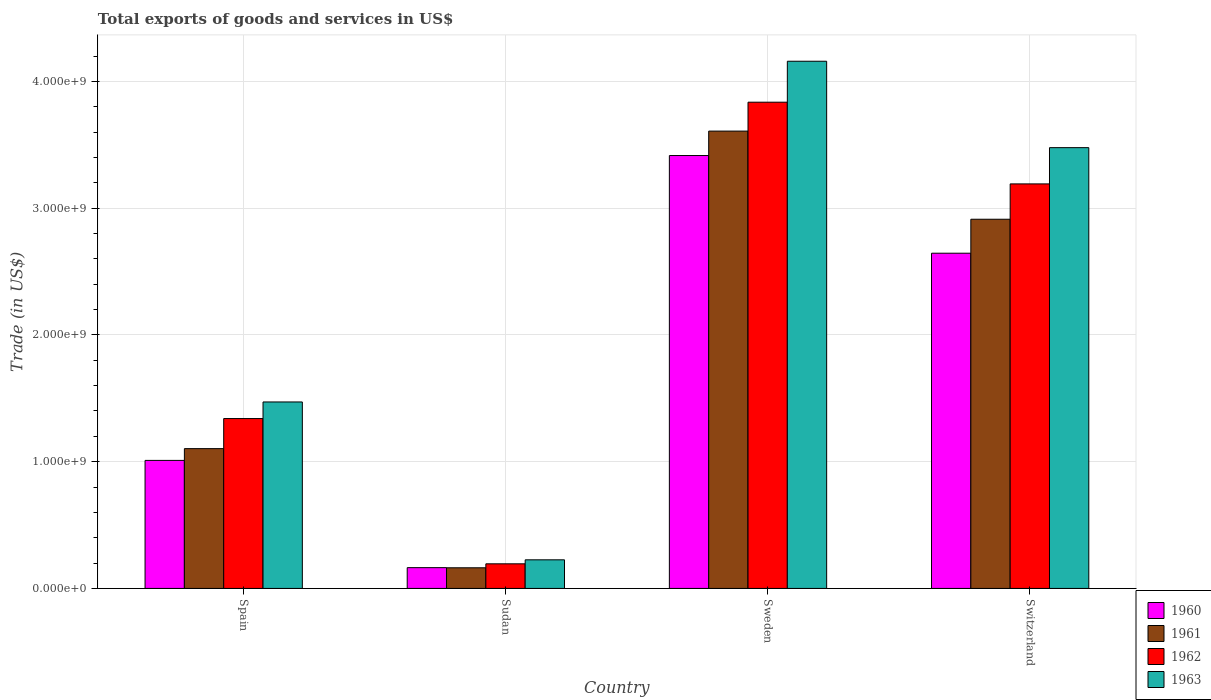Are the number of bars per tick equal to the number of legend labels?
Ensure brevity in your answer.  Yes. Are the number of bars on each tick of the X-axis equal?
Your response must be concise. Yes. What is the total exports of goods and services in 1963 in Switzerland?
Ensure brevity in your answer.  3.48e+09. Across all countries, what is the maximum total exports of goods and services in 1960?
Offer a terse response. 3.42e+09. Across all countries, what is the minimum total exports of goods and services in 1963?
Your response must be concise. 2.26e+08. In which country was the total exports of goods and services in 1963 maximum?
Ensure brevity in your answer.  Sweden. In which country was the total exports of goods and services in 1963 minimum?
Ensure brevity in your answer.  Sudan. What is the total total exports of goods and services in 1960 in the graph?
Give a very brief answer. 7.23e+09. What is the difference between the total exports of goods and services in 1960 in Sudan and that in Switzerland?
Make the answer very short. -2.48e+09. What is the difference between the total exports of goods and services in 1961 in Switzerland and the total exports of goods and services in 1962 in Spain?
Keep it short and to the point. 1.57e+09. What is the average total exports of goods and services in 1962 per country?
Ensure brevity in your answer.  2.14e+09. What is the difference between the total exports of goods and services of/in 1962 and total exports of goods and services of/in 1960 in Switzerland?
Your answer should be very brief. 5.47e+08. In how many countries, is the total exports of goods and services in 1963 greater than 2800000000 US$?
Your answer should be very brief. 2. What is the ratio of the total exports of goods and services in 1961 in Sudan to that in Sweden?
Your answer should be compact. 0.05. Is the total exports of goods and services in 1963 in Spain less than that in Switzerland?
Provide a succinct answer. Yes. Is the difference between the total exports of goods and services in 1962 in Spain and Sudan greater than the difference between the total exports of goods and services in 1960 in Spain and Sudan?
Your answer should be very brief. Yes. What is the difference between the highest and the second highest total exports of goods and services in 1960?
Offer a terse response. -7.71e+08. What is the difference between the highest and the lowest total exports of goods and services in 1961?
Your response must be concise. 3.44e+09. Is the sum of the total exports of goods and services in 1960 in Sweden and Switzerland greater than the maximum total exports of goods and services in 1963 across all countries?
Give a very brief answer. Yes. Is it the case that in every country, the sum of the total exports of goods and services in 1961 and total exports of goods and services in 1960 is greater than the sum of total exports of goods and services in 1962 and total exports of goods and services in 1963?
Offer a very short reply. No. What does the 2nd bar from the left in Switzerland represents?
Give a very brief answer. 1961. What does the 4th bar from the right in Switzerland represents?
Provide a succinct answer. 1960. Is it the case that in every country, the sum of the total exports of goods and services in 1961 and total exports of goods and services in 1962 is greater than the total exports of goods and services in 1960?
Offer a terse response. Yes. How many bars are there?
Provide a succinct answer. 16. Are all the bars in the graph horizontal?
Your answer should be compact. No. How many countries are there in the graph?
Provide a short and direct response. 4. What is the difference between two consecutive major ticks on the Y-axis?
Ensure brevity in your answer.  1.00e+09. Does the graph contain any zero values?
Your answer should be very brief. No. Where does the legend appear in the graph?
Ensure brevity in your answer.  Bottom right. How many legend labels are there?
Your answer should be very brief. 4. How are the legend labels stacked?
Provide a succinct answer. Vertical. What is the title of the graph?
Your answer should be very brief. Total exports of goods and services in US$. Does "1971" appear as one of the legend labels in the graph?
Make the answer very short. No. What is the label or title of the X-axis?
Keep it short and to the point. Country. What is the label or title of the Y-axis?
Give a very brief answer. Trade (in US$). What is the Trade (in US$) of 1960 in Spain?
Your answer should be very brief. 1.01e+09. What is the Trade (in US$) of 1961 in Spain?
Make the answer very short. 1.10e+09. What is the Trade (in US$) of 1962 in Spain?
Offer a very short reply. 1.34e+09. What is the Trade (in US$) in 1963 in Spain?
Keep it short and to the point. 1.47e+09. What is the Trade (in US$) in 1960 in Sudan?
Provide a succinct answer. 1.64e+08. What is the Trade (in US$) in 1961 in Sudan?
Ensure brevity in your answer.  1.63e+08. What is the Trade (in US$) of 1962 in Sudan?
Offer a terse response. 1.94e+08. What is the Trade (in US$) of 1963 in Sudan?
Keep it short and to the point. 2.26e+08. What is the Trade (in US$) in 1960 in Sweden?
Keep it short and to the point. 3.42e+09. What is the Trade (in US$) in 1961 in Sweden?
Your answer should be very brief. 3.61e+09. What is the Trade (in US$) of 1962 in Sweden?
Ensure brevity in your answer.  3.84e+09. What is the Trade (in US$) of 1963 in Sweden?
Offer a terse response. 4.16e+09. What is the Trade (in US$) of 1960 in Switzerland?
Provide a succinct answer. 2.64e+09. What is the Trade (in US$) in 1961 in Switzerland?
Make the answer very short. 2.91e+09. What is the Trade (in US$) in 1962 in Switzerland?
Give a very brief answer. 3.19e+09. What is the Trade (in US$) in 1963 in Switzerland?
Your answer should be compact. 3.48e+09. Across all countries, what is the maximum Trade (in US$) in 1960?
Give a very brief answer. 3.42e+09. Across all countries, what is the maximum Trade (in US$) in 1961?
Make the answer very short. 3.61e+09. Across all countries, what is the maximum Trade (in US$) of 1962?
Provide a short and direct response. 3.84e+09. Across all countries, what is the maximum Trade (in US$) of 1963?
Keep it short and to the point. 4.16e+09. Across all countries, what is the minimum Trade (in US$) of 1960?
Provide a succinct answer. 1.64e+08. Across all countries, what is the minimum Trade (in US$) in 1961?
Provide a succinct answer. 1.63e+08. Across all countries, what is the minimum Trade (in US$) of 1962?
Give a very brief answer. 1.94e+08. Across all countries, what is the minimum Trade (in US$) of 1963?
Provide a succinct answer. 2.26e+08. What is the total Trade (in US$) of 1960 in the graph?
Provide a succinct answer. 7.23e+09. What is the total Trade (in US$) in 1961 in the graph?
Ensure brevity in your answer.  7.79e+09. What is the total Trade (in US$) in 1962 in the graph?
Provide a succinct answer. 8.56e+09. What is the total Trade (in US$) of 1963 in the graph?
Your answer should be compact. 9.33e+09. What is the difference between the Trade (in US$) in 1960 in Spain and that in Sudan?
Your answer should be very brief. 8.46e+08. What is the difference between the Trade (in US$) of 1961 in Spain and that in Sudan?
Provide a succinct answer. 9.40e+08. What is the difference between the Trade (in US$) of 1962 in Spain and that in Sudan?
Give a very brief answer. 1.15e+09. What is the difference between the Trade (in US$) of 1963 in Spain and that in Sudan?
Your answer should be compact. 1.25e+09. What is the difference between the Trade (in US$) in 1960 in Spain and that in Sweden?
Provide a succinct answer. -2.40e+09. What is the difference between the Trade (in US$) of 1961 in Spain and that in Sweden?
Your answer should be very brief. -2.50e+09. What is the difference between the Trade (in US$) of 1962 in Spain and that in Sweden?
Your response must be concise. -2.50e+09. What is the difference between the Trade (in US$) of 1963 in Spain and that in Sweden?
Your response must be concise. -2.69e+09. What is the difference between the Trade (in US$) in 1960 in Spain and that in Switzerland?
Give a very brief answer. -1.63e+09. What is the difference between the Trade (in US$) in 1961 in Spain and that in Switzerland?
Your answer should be compact. -1.81e+09. What is the difference between the Trade (in US$) of 1962 in Spain and that in Switzerland?
Make the answer very short. -1.85e+09. What is the difference between the Trade (in US$) in 1963 in Spain and that in Switzerland?
Your answer should be compact. -2.01e+09. What is the difference between the Trade (in US$) in 1960 in Sudan and that in Sweden?
Ensure brevity in your answer.  -3.25e+09. What is the difference between the Trade (in US$) in 1961 in Sudan and that in Sweden?
Provide a succinct answer. -3.44e+09. What is the difference between the Trade (in US$) in 1962 in Sudan and that in Sweden?
Your answer should be compact. -3.64e+09. What is the difference between the Trade (in US$) in 1963 in Sudan and that in Sweden?
Your answer should be very brief. -3.93e+09. What is the difference between the Trade (in US$) of 1960 in Sudan and that in Switzerland?
Give a very brief answer. -2.48e+09. What is the difference between the Trade (in US$) in 1961 in Sudan and that in Switzerland?
Your answer should be very brief. -2.75e+09. What is the difference between the Trade (in US$) in 1962 in Sudan and that in Switzerland?
Your response must be concise. -3.00e+09. What is the difference between the Trade (in US$) of 1963 in Sudan and that in Switzerland?
Provide a short and direct response. -3.25e+09. What is the difference between the Trade (in US$) in 1960 in Sweden and that in Switzerland?
Your answer should be very brief. 7.71e+08. What is the difference between the Trade (in US$) of 1961 in Sweden and that in Switzerland?
Your response must be concise. 6.95e+08. What is the difference between the Trade (in US$) of 1962 in Sweden and that in Switzerland?
Make the answer very short. 6.45e+08. What is the difference between the Trade (in US$) in 1963 in Sweden and that in Switzerland?
Your answer should be compact. 6.82e+08. What is the difference between the Trade (in US$) of 1960 in Spain and the Trade (in US$) of 1961 in Sudan?
Give a very brief answer. 8.47e+08. What is the difference between the Trade (in US$) in 1960 in Spain and the Trade (in US$) in 1962 in Sudan?
Provide a succinct answer. 8.16e+08. What is the difference between the Trade (in US$) in 1960 in Spain and the Trade (in US$) in 1963 in Sudan?
Make the answer very short. 7.84e+08. What is the difference between the Trade (in US$) in 1961 in Spain and the Trade (in US$) in 1962 in Sudan?
Offer a very short reply. 9.09e+08. What is the difference between the Trade (in US$) in 1961 in Spain and the Trade (in US$) in 1963 in Sudan?
Offer a very short reply. 8.77e+08. What is the difference between the Trade (in US$) in 1962 in Spain and the Trade (in US$) in 1963 in Sudan?
Your response must be concise. 1.11e+09. What is the difference between the Trade (in US$) of 1960 in Spain and the Trade (in US$) of 1961 in Sweden?
Provide a succinct answer. -2.60e+09. What is the difference between the Trade (in US$) in 1960 in Spain and the Trade (in US$) in 1962 in Sweden?
Your answer should be compact. -2.83e+09. What is the difference between the Trade (in US$) in 1960 in Spain and the Trade (in US$) in 1963 in Sweden?
Offer a terse response. -3.15e+09. What is the difference between the Trade (in US$) of 1961 in Spain and the Trade (in US$) of 1962 in Sweden?
Make the answer very short. -2.73e+09. What is the difference between the Trade (in US$) in 1961 in Spain and the Trade (in US$) in 1963 in Sweden?
Give a very brief answer. -3.06e+09. What is the difference between the Trade (in US$) of 1962 in Spain and the Trade (in US$) of 1963 in Sweden?
Your answer should be compact. -2.82e+09. What is the difference between the Trade (in US$) of 1960 in Spain and the Trade (in US$) of 1961 in Switzerland?
Offer a very short reply. -1.90e+09. What is the difference between the Trade (in US$) in 1960 in Spain and the Trade (in US$) in 1962 in Switzerland?
Your answer should be very brief. -2.18e+09. What is the difference between the Trade (in US$) of 1960 in Spain and the Trade (in US$) of 1963 in Switzerland?
Keep it short and to the point. -2.47e+09. What is the difference between the Trade (in US$) in 1961 in Spain and the Trade (in US$) in 1962 in Switzerland?
Provide a succinct answer. -2.09e+09. What is the difference between the Trade (in US$) in 1961 in Spain and the Trade (in US$) in 1963 in Switzerland?
Keep it short and to the point. -2.37e+09. What is the difference between the Trade (in US$) of 1962 in Spain and the Trade (in US$) of 1963 in Switzerland?
Offer a terse response. -2.14e+09. What is the difference between the Trade (in US$) of 1960 in Sudan and the Trade (in US$) of 1961 in Sweden?
Provide a short and direct response. -3.44e+09. What is the difference between the Trade (in US$) of 1960 in Sudan and the Trade (in US$) of 1962 in Sweden?
Make the answer very short. -3.67e+09. What is the difference between the Trade (in US$) in 1960 in Sudan and the Trade (in US$) in 1963 in Sweden?
Your answer should be compact. -3.99e+09. What is the difference between the Trade (in US$) of 1961 in Sudan and the Trade (in US$) of 1962 in Sweden?
Provide a succinct answer. -3.67e+09. What is the difference between the Trade (in US$) of 1961 in Sudan and the Trade (in US$) of 1963 in Sweden?
Your answer should be very brief. -4.00e+09. What is the difference between the Trade (in US$) of 1962 in Sudan and the Trade (in US$) of 1963 in Sweden?
Provide a short and direct response. -3.96e+09. What is the difference between the Trade (in US$) in 1960 in Sudan and the Trade (in US$) in 1961 in Switzerland?
Keep it short and to the point. -2.75e+09. What is the difference between the Trade (in US$) of 1960 in Sudan and the Trade (in US$) of 1962 in Switzerland?
Provide a succinct answer. -3.03e+09. What is the difference between the Trade (in US$) in 1960 in Sudan and the Trade (in US$) in 1963 in Switzerland?
Your response must be concise. -3.31e+09. What is the difference between the Trade (in US$) in 1961 in Sudan and the Trade (in US$) in 1962 in Switzerland?
Ensure brevity in your answer.  -3.03e+09. What is the difference between the Trade (in US$) of 1961 in Sudan and the Trade (in US$) of 1963 in Switzerland?
Provide a succinct answer. -3.31e+09. What is the difference between the Trade (in US$) of 1962 in Sudan and the Trade (in US$) of 1963 in Switzerland?
Your answer should be very brief. -3.28e+09. What is the difference between the Trade (in US$) of 1960 in Sweden and the Trade (in US$) of 1961 in Switzerland?
Your answer should be compact. 5.03e+08. What is the difference between the Trade (in US$) of 1960 in Sweden and the Trade (in US$) of 1962 in Switzerland?
Keep it short and to the point. 2.24e+08. What is the difference between the Trade (in US$) of 1960 in Sweden and the Trade (in US$) of 1963 in Switzerland?
Provide a short and direct response. -6.23e+07. What is the difference between the Trade (in US$) of 1961 in Sweden and the Trade (in US$) of 1962 in Switzerland?
Keep it short and to the point. 4.17e+08. What is the difference between the Trade (in US$) of 1961 in Sweden and the Trade (in US$) of 1963 in Switzerland?
Your answer should be compact. 1.30e+08. What is the difference between the Trade (in US$) in 1962 in Sweden and the Trade (in US$) in 1963 in Switzerland?
Provide a short and direct response. 3.59e+08. What is the average Trade (in US$) in 1960 per country?
Keep it short and to the point. 1.81e+09. What is the average Trade (in US$) of 1961 per country?
Provide a short and direct response. 1.95e+09. What is the average Trade (in US$) in 1962 per country?
Provide a succinct answer. 2.14e+09. What is the average Trade (in US$) of 1963 per country?
Your answer should be compact. 2.33e+09. What is the difference between the Trade (in US$) of 1960 and Trade (in US$) of 1961 in Spain?
Offer a terse response. -9.29e+07. What is the difference between the Trade (in US$) in 1960 and Trade (in US$) in 1962 in Spain?
Keep it short and to the point. -3.30e+08. What is the difference between the Trade (in US$) in 1960 and Trade (in US$) in 1963 in Spain?
Your answer should be compact. -4.61e+08. What is the difference between the Trade (in US$) of 1961 and Trade (in US$) of 1962 in Spain?
Provide a succinct answer. -2.37e+08. What is the difference between the Trade (in US$) of 1961 and Trade (in US$) of 1963 in Spain?
Provide a succinct answer. -3.68e+08. What is the difference between the Trade (in US$) of 1962 and Trade (in US$) of 1963 in Spain?
Make the answer very short. -1.31e+08. What is the difference between the Trade (in US$) of 1960 and Trade (in US$) of 1961 in Sudan?
Your answer should be compact. 1.15e+06. What is the difference between the Trade (in US$) of 1960 and Trade (in US$) of 1962 in Sudan?
Provide a succinct answer. -3.02e+07. What is the difference between the Trade (in US$) in 1960 and Trade (in US$) in 1963 in Sudan?
Give a very brief answer. -6.17e+07. What is the difference between the Trade (in US$) in 1961 and Trade (in US$) in 1962 in Sudan?
Provide a succinct answer. -3.13e+07. What is the difference between the Trade (in US$) in 1961 and Trade (in US$) in 1963 in Sudan?
Keep it short and to the point. -6.29e+07. What is the difference between the Trade (in US$) of 1962 and Trade (in US$) of 1963 in Sudan?
Your answer should be compact. -3.16e+07. What is the difference between the Trade (in US$) of 1960 and Trade (in US$) of 1961 in Sweden?
Provide a succinct answer. -1.93e+08. What is the difference between the Trade (in US$) of 1960 and Trade (in US$) of 1962 in Sweden?
Provide a short and direct response. -4.21e+08. What is the difference between the Trade (in US$) of 1960 and Trade (in US$) of 1963 in Sweden?
Offer a very short reply. -7.44e+08. What is the difference between the Trade (in US$) in 1961 and Trade (in US$) in 1962 in Sweden?
Keep it short and to the point. -2.28e+08. What is the difference between the Trade (in US$) of 1961 and Trade (in US$) of 1963 in Sweden?
Provide a short and direct response. -5.51e+08. What is the difference between the Trade (in US$) in 1962 and Trade (in US$) in 1963 in Sweden?
Offer a terse response. -3.23e+08. What is the difference between the Trade (in US$) in 1960 and Trade (in US$) in 1961 in Switzerland?
Provide a short and direct response. -2.68e+08. What is the difference between the Trade (in US$) of 1960 and Trade (in US$) of 1962 in Switzerland?
Your response must be concise. -5.47e+08. What is the difference between the Trade (in US$) of 1960 and Trade (in US$) of 1963 in Switzerland?
Ensure brevity in your answer.  -8.33e+08. What is the difference between the Trade (in US$) of 1961 and Trade (in US$) of 1962 in Switzerland?
Your answer should be very brief. -2.79e+08. What is the difference between the Trade (in US$) of 1961 and Trade (in US$) of 1963 in Switzerland?
Give a very brief answer. -5.65e+08. What is the difference between the Trade (in US$) in 1962 and Trade (in US$) in 1963 in Switzerland?
Offer a very short reply. -2.86e+08. What is the ratio of the Trade (in US$) in 1960 in Spain to that in Sudan?
Offer a very short reply. 6.16. What is the ratio of the Trade (in US$) in 1961 in Spain to that in Sudan?
Provide a succinct answer. 6.77. What is the ratio of the Trade (in US$) in 1962 in Spain to that in Sudan?
Offer a terse response. 6.9. What is the ratio of the Trade (in US$) of 1963 in Spain to that in Sudan?
Make the answer very short. 6.52. What is the ratio of the Trade (in US$) in 1960 in Spain to that in Sweden?
Your response must be concise. 0.3. What is the ratio of the Trade (in US$) in 1961 in Spain to that in Sweden?
Your response must be concise. 0.31. What is the ratio of the Trade (in US$) in 1962 in Spain to that in Sweden?
Offer a terse response. 0.35. What is the ratio of the Trade (in US$) in 1963 in Spain to that in Sweden?
Ensure brevity in your answer.  0.35. What is the ratio of the Trade (in US$) of 1960 in Spain to that in Switzerland?
Your answer should be very brief. 0.38. What is the ratio of the Trade (in US$) of 1961 in Spain to that in Switzerland?
Your response must be concise. 0.38. What is the ratio of the Trade (in US$) of 1962 in Spain to that in Switzerland?
Offer a very short reply. 0.42. What is the ratio of the Trade (in US$) in 1963 in Spain to that in Switzerland?
Your answer should be very brief. 0.42. What is the ratio of the Trade (in US$) of 1960 in Sudan to that in Sweden?
Your answer should be compact. 0.05. What is the ratio of the Trade (in US$) of 1961 in Sudan to that in Sweden?
Keep it short and to the point. 0.05. What is the ratio of the Trade (in US$) in 1962 in Sudan to that in Sweden?
Offer a terse response. 0.05. What is the ratio of the Trade (in US$) of 1963 in Sudan to that in Sweden?
Make the answer very short. 0.05. What is the ratio of the Trade (in US$) of 1960 in Sudan to that in Switzerland?
Keep it short and to the point. 0.06. What is the ratio of the Trade (in US$) of 1961 in Sudan to that in Switzerland?
Your answer should be compact. 0.06. What is the ratio of the Trade (in US$) of 1962 in Sudan to that in Switzerland?
Your answer should be compact. 0.06. What is the ratio of the Trade (in US$) of 1963 in Sudan to that in Switzerland?
Your response must be concise. 0.06. What is the ratio of the Trade (in US$) of 1960 in Sweden to that in Switzerland?
Your answer should be very brief. 1.29. What is the ratio of the Trade (in US$) of 1961 in Sweden to that in Switzerland?
Provide a short and direct response. 1.24. What is the ratio of the Trade (in US$) in 1962 in Sweden to that in Switzerland?
Your answer should be compact. 1.2. What is the ratio of the Trade (in US$) of 1963 in Sweden to that in Switzerland?
Offer a terse response. 1.2. What is the difference between the highest and the second highest Trade (in US$) of 1960?
Provide a short and direct response. 7.71e+08. What is the difference between the highest and the second highest Trade (in US$) of 1961?
Offer a very short reply. 6.95e+08. What is the difference between the highest and the second highest Trade (in US$) in 1962?
Offer a very short reply. 6.45e+08. What is the difference between the highest and the second highest Trade (in US$) in 1963?
Ensure brevity in your answer.  6.82e+08. What is the difference between the highest and the lowest Trade (in US$) of 1960?
Keep it short and to the point. 3.25e+09. What is the difference between the highest and the lowest Trade (in US$) in 1961?
Provide a succinct answer. 3.44e+09. What is the difference between the highest and the lowest Trade (in US$) in 1962?
Provide a succinct answer. 3.64e+09. What is the difference between the highest and the lowest Trade (in US$) in 1963?
Your response must be concise. 3.93e+09. 